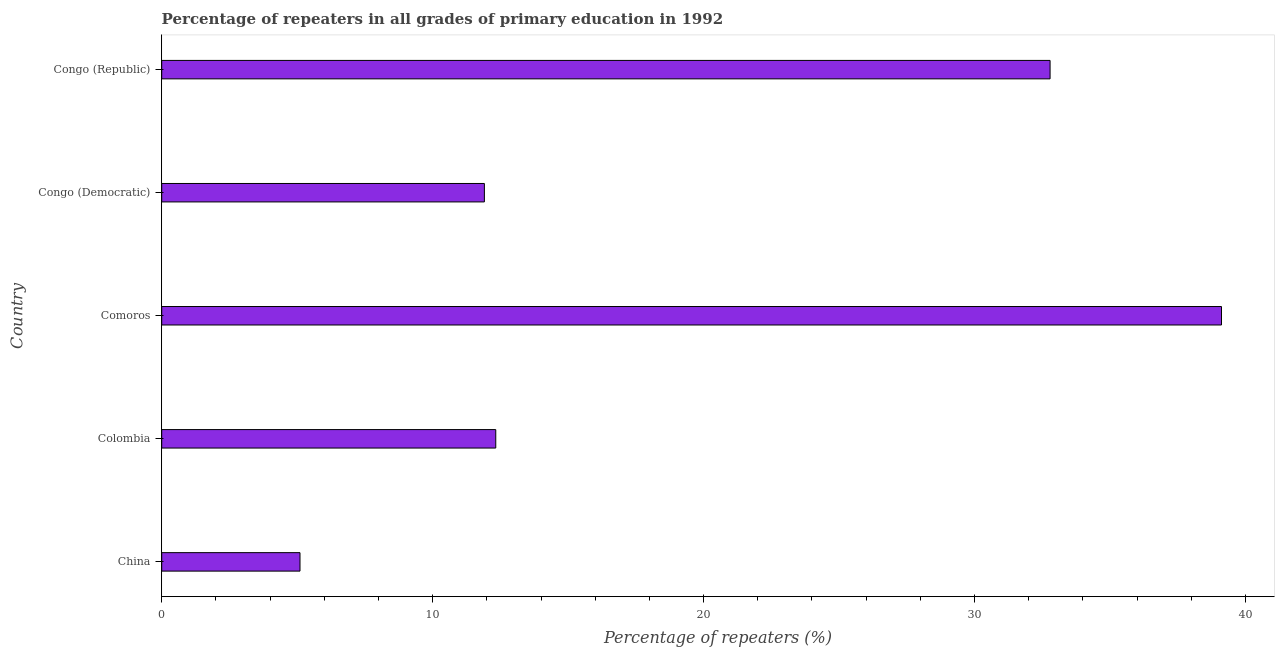What is the title of the graph?
Offer a very short reply. Percentage of repeaters in all grades of primary education in 1992. What is the label or title of the X-axis?
Keep it short and to the point. Percentage of repeaters (%). What is the percentage of repeaters in primary education in China?
Offer a terse response. 5.1. Across all countries, what is the maximum percentage of repeaters in primary education?
Your answer should be compact. 39.12. Across all countries, what is the minimum percentage of repeaters in primary education?
Give a very brief answer. 5.1. In which country was the percentage of repeaters in primary education maximum?
Make the answer very short. Comoros. What is the sum of the percentage of repeaters in primary education?
Your response must be concise. 101.25. What is the difference between the percentage of repeaters in primary education in China and Congo (Republic)?
Make the answer very short. -27.69. What is the average percentage of repeaters in primary education per country?
Ensure brevity in your answer.  20.25. What is the median percentage of repeaters in primary education?
Make the answer very short. 12.33. What is the ratio of the percentage of repeaters in primary education in Comoros to that in Congo (Democratic)?
Offer a very short reply. 3.28. Is the percentage of repeaters in primary education in Colombia less than that in Comoros?
Offer a terse response. Yes. Is the difference between the percentage of repeaters in primary education in Congo (Democratic) and Congo (Republic) greater than the difference between any two countries?
Your answer should be compact. No. What is the difference between the highest and the second highest percentage of repeaters in primary education?
Your answer should be very brief. 6.33. Is the sum of the percentage of repeaters in primary education in Colombia and Congo (Republic) greater than the maximum percentage of repeaters in primary education across all countries?
Ensure brevity in your answer.  Yes. What is the difference between the highest and the lowest percentage of repeaters in primary education?
Give a very brief answer. 34.01. How many bars are there?
Offer a very short reply. 5. Are all the bars in the graph horizontal?
Your answer should be very brief. Yes. What is the difference between two consecutive major ticks on the X-axis?
Keep it short and to the point. 10. Are the values on the major ticks of X-axis written in scientific E-notation?
Your response must be concise. No. What is the Percentage of repeaters (%) in China?
Offer a very short reply. 5.1. What is the Percentage of repeaters (%) in Colombia?
Offer a very short reply. 12.33. What is the Percentage of repeaters (%) of Comoros?
Provide a succinct answer. 39.12. What is the Percentage of repeaters (%) in Congo (Democratic)?
Make the answer very short. 11.91. What is the Percentage of repeaters (%) of Congo (Republic)?
Your response must be concise. 32.79. What is the difference between the Percentage of repeaters (%) in China and Colombia?
Offer a terse response. -7.23. What is the difference between the Percentage of repeaters (%) in China and Comoros?
Offer a terse response. -34.01. What is the difference between the Percentage of repeaters (%) in China and Congo (Democratic)?
Your answer should be very brief. -6.81. What is the difference between the Percentage of repeaters (%) in China and Congo (Republic)?
Make the answer very short. -27.69. What is the difference between the Percentage of repeaters (%) in Colombia and Comoros?
Provide a succinct answer. -26.79. What is the difference between the Percentage of repeaters (%) in Colombia and Congo (Democratic)?
Offer a very short reply. 0.42. What is the difference between the Percentage of repeaters (%) in Colombia and Congo (Republic)?
Keep it short and to the point. -20.46. What is the difference between the Percentage of repeaters (%) in Comoros and Congo (Democratic)?
Provide a short and direct response. 27.21. What is the difference between the Percentage of repeaters (%) in Comoros and Congo (Republic)?
Ensure brevity in your answer.  6.33. What is the difference between the Percentage of repeaters (%) in Congo (Democratic) and Congo (Republic)?
Your response must be concise. -20.88. What is the ratio of the Percentage of repeaters (%) in China to that in Colombia?
Ensure brevity in your answer.  0.41. What is the ratio of the Percentage of repeaters (%) in China to that in Comoros?
Ensure brevity in your answer.  0.13. What is the ratio of the Percentage of repeaters (%) in China to that in Congo (Democratic)?
Your answer should be compact. 0.43. What is the ratio of the Percentage of repeaters (%) in China to that in Congo (Republic)?
Your answer should be compact. 0.16. What is the ratio of the Percentage of repeaters (%) in Colombia to that in Comoros?
Offer a very short reply. 0.32. What is the ratio of the Percentage of repeaters (%) in Colombia to that in Congo (Democratic)?
Your answer should be very brief. 1.03. What is the ratio of the Percentage of repeaters (%) in Colombia to that in Congo (Republic)?
Provide a succinct answer. 0.38. What is the ratio of the Percentage of repeaters (%) in Comoros to that in Congo (Democratic)?
Keep it short and to the point. 3.28. What is the ratio of the Percentage of repeaters (%) in Comoros to that in Congo (Republic)?
Offer a terse response. 1.19. What is the ratio of the Percentage of repeaters (%) in Congo (Democratic) to that in Congo (Republic)?
Your answer should be compact. 0.36. 